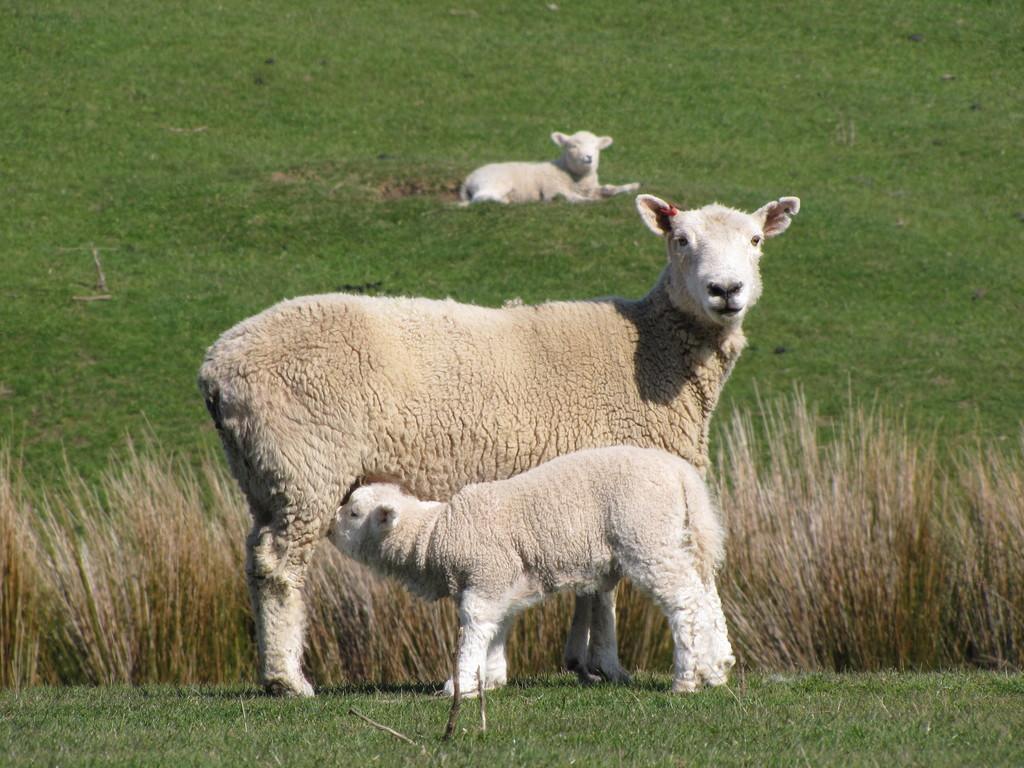In one or two sentences, can you explain what this image depicts? In the picture we can see a sheep standing on the grass surface near it, we can see a lamb and behind it, we can see dried grass and in the background, we can see a grass surface on it we can see a sheep sitting. 